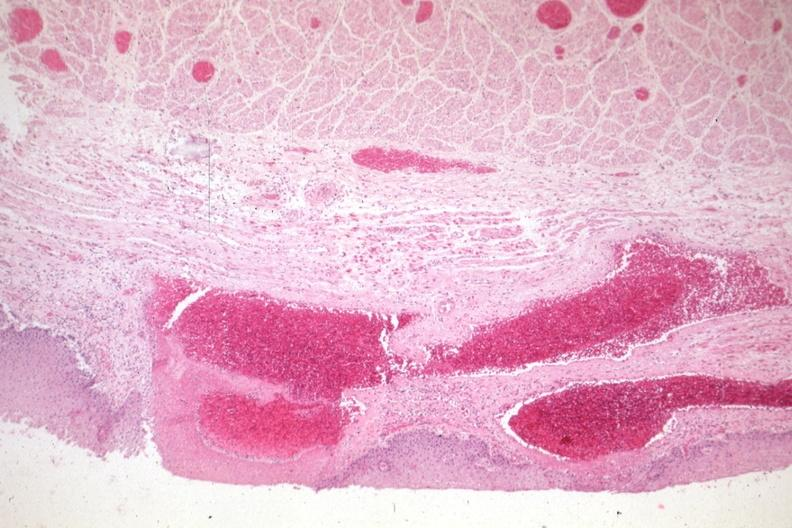what is present?
Answer the question using a single word or phrase. Gastrointestinal 